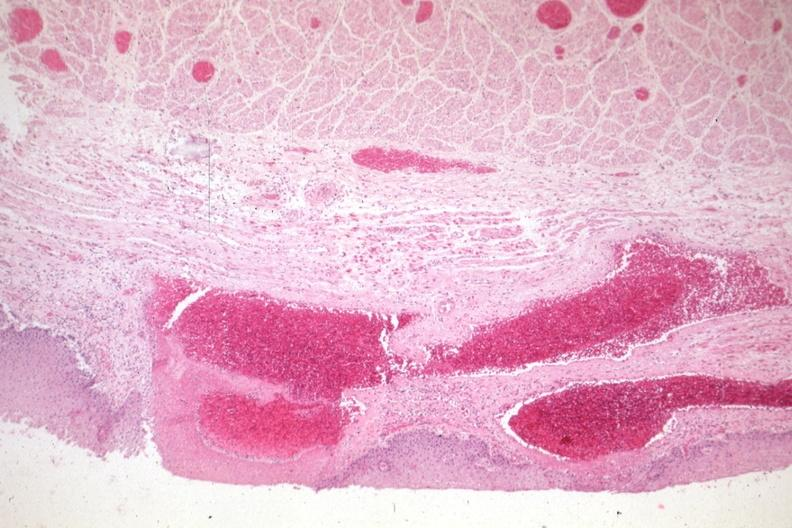what is present?
Answer the question using a single word or phrase. Gastrointestinal 